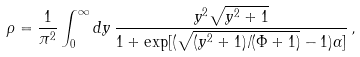<formula> <loc_0><loc_0><loc_500><loc_500>\rho = \frac { 1 } { \pi ^ { 2 } } \int ^ { \infty } _ { 0 } d y \, \frac { y ^ { 2 } \sqrt { y ^ { 2 } + 1 } } { 1 + \exp [ ( \sqrt { ( y ^ { 2 } + 1 ) / ( \Phi + 1 ) } - 1 ) \alpha ] } \, ,</formula> 